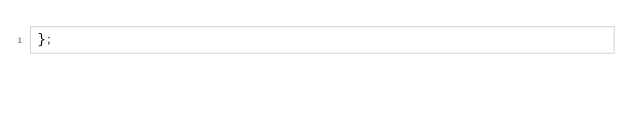<code> <loc_0><loc_0><loc_500><loc_500><_JavaScript_>};
</code> 